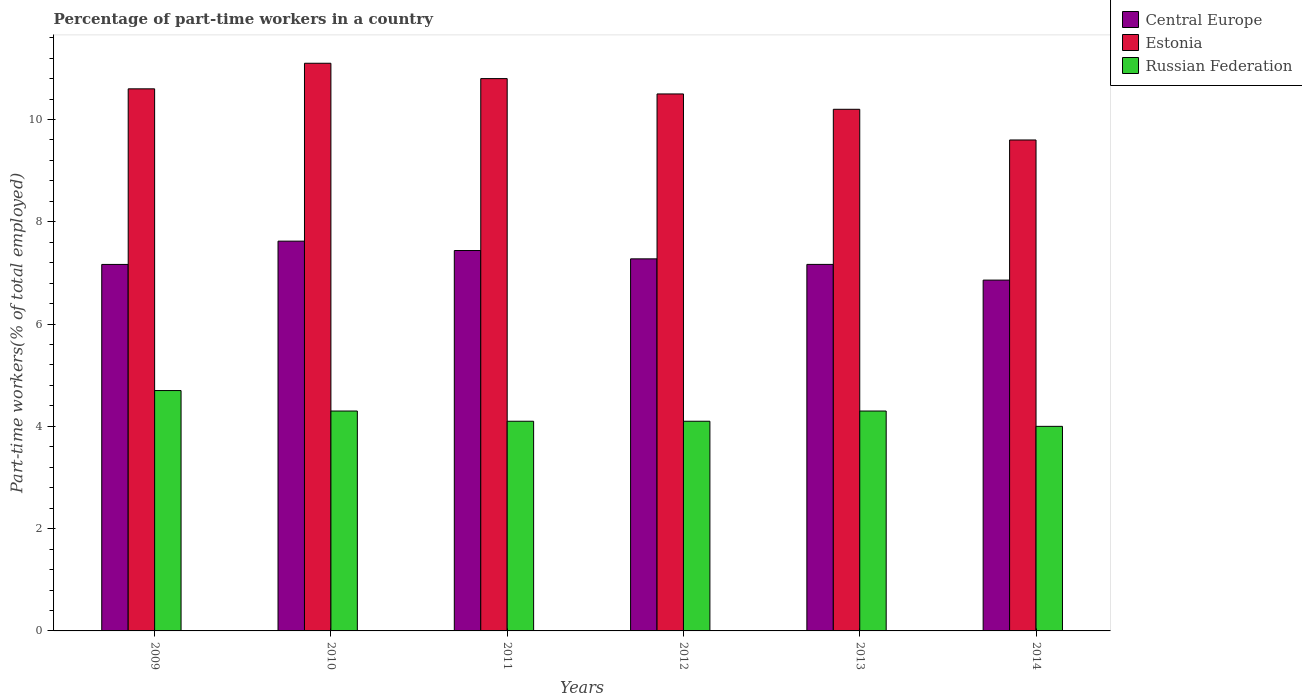Are the number of bars per tick equal to the number of legend labels?
Provide a short and direct response. Yes. Are the number of bars on each tick of the X-axis equal?
Ensure brevity in your answer.  Yes. How many bars are there on the 3rd tick from the right?
Your response must be concise. 3. What is the percentage of part-time workers in Central Europe in 2010?
Ensure brevity in your answer.  7.62. Across all years, what is the maximum percentage of part-time workers in Central Europe?
Provide a succinct answer. 7.62. Across all years, what is the minimum percentage of part-time workers in Central Europe?
Make the answer very short. 6.86. In which year was the percentage of part-time workers in Central Europe maximum?
Provide a succinct answer. 2010. In which year was the percentage of part-time workers in Russian Federation minimum?
Keep it short and to the point. 2014. What is the total percentage of part-time workers in Estonia in the graph?
Make the answer very short. 62.8. What is the difference between the percentage of part-time workers in Russian Federation in 2009 and that in 2012?
Make the answer very short. 0.6. What is the difference between the percentage of part-time workers in Russian Federation in 2010 and the percentage of part-time workers in Central Europe in 2013?
Your response must be concise. -2.87. What is the average percentage of part-time workers in Estonia per year?
Ensure brevity in your answer.  10.47. In the year 2010, what is the difference between the percentage of part-time workers in Russian Federation and percentage of part-time workers in Estonia?
Make the answer very short. -6.8. In how many years, is the percentage of part-time workers in Russian Federation greater than 6 %?
Offer a terse response. 0. What is the ratio of the percentage of part-time workers in Central Europe in 2012 to that in 2013?
Provide a short and direct response. 1.02. Is the difference between the percentage of part-time workers in Russian Federation in 2012 and 2014 greater than the difference between the percentage of part-time workers in Estonia in 2012 and 2014?
Give a very brief answer. No. What is the difference between the highest and the second highest percentage of part-time workers in Estonia?
Offer a terse response. 0.3. What is the difference between the highest and the lowest percentage of part-time workers in Russian Federation?
Your answer should be very brief. 0.7. In how many years, is the percentage of part-time workers in Central Europe greater than the average percentage of part-time workers in Central Europe taken over all years?
Give a very brief answer. 3. Is the sum of the percentage of part-time workers in Estonia in 2009 and 2013 greater than the maximum percentage of part-time workers in Russian Federation across all years?
Your answer should be very brief. Yes. What does the 2nd bar from the left in 2011 represents?
Your answer should be compact. Estonia. What does the 2nd bar from the right in 2013 represents?
Keep it short and to the point. Estonia. How many years are there in the graph?
Your answer should be very brief. 6. Does the graph contain any zero values?
Provide a short and direct response. No. Where does the legend appear in the graph?
Your answer should be very brief. Top right. How many legend labels are there?
Give a very brief answer. 3. How are the legend labels stacked?
Provide a succinct answer. Vertical. What is the title of the graph?
Your answer should be very brief. Percentage of part-time workers in a country. Does "Spain" appear as one of the legend labels in the graph?
Provide a short and direct response. No. What is the label or title of the X-axis?
Your answer should be compact. Years. What is the label or title of the Y-axis?
Offer a terse response. Part-time workers(% of total employed). What is the Part-time workers(% of total employed) in Central Europe in 2009?
Offer a very short reply. 7.17. What is the Part-time workers(% of total employed) of Estonia in 2009?
Ensure brevity in your answer.  10.6. What is the Part-time workers(% of total employed) in Russian Federation in 2009?
Keep it short and to the point. 4.7. What is the Part-time workers(% of total employed) in Central Europe in 2010?
Offer a very short reply. 7.62. What is the Part-time workers(% of total employed) in Estonia in 2010?
Ensure brevity in your answer.  11.1. What is the Part-time workers(% of total employed) of Russian Federation in 2010?
Your answer should be compact. 4.3. What is the Part-time workers(% of total employed) in Central Europe in 2011?
Offer a terse response. 7.44. What is the Part-time workers(% of total employed) of Estonia in 2011?
Offer a very short reply. 10.8. What is the Part-time workers(% of total employed) of Russian Federation in 2011?
Ensure brevity in your answer.  4.1. What is the Part-time workers(% of total employed) in Central Europe in 2012?
Ensure brevity in your answer.  7.28. What is the Part-time workers(% of total employed) of Russian Federation in 2012?
Provide a short and direct response. 4.1. What is the Part-time workers(% of total employed) of Central Europe in 2013?
Provide a succinct answer. 7.17. What is the Part-time workers(% of total employed) in Estonia in 2013?
Your answer should be compact. 10.2. What is the Part-time workers(% of total employed) in Russian Federation in 2013?
Your answer should be compact. 4.3. What is the Part-time workers(% of total employed) of Central Europe in 2014?
Ensure brevity in your answer.  6.86. What is the Part-time workers(% of total employed) of Estonia in 2014?
Offer a very short reply. 9.6. What is the Part-time workers(% of total employed) of Russian Federation in 2014?
Make the answer very short. 4. Across all years, what is the maximum Part-time workers(% of total employed) of Central Europe?
Make the answer very short. 7.62. Across all years, what is the maximum Part-time workers(% of total employed) of Estonia?
Provide a succinct answer. 11.1. Across all years, what is the maximum Part-time workers(% of total employed) in Russian Federation?
Your response must be concise. 4.7. Across all years, what is the minimum Part-time workers(% of total employed) of Central Europe?
Ensure brevity in your answer.  6.86. Across all years, what is the minimum Part-time workers(% of total employed) of Estonia?
Your answer should be very brief. 9.6. What is the total Part-time workers(% of total employed) in Central Europe in the graph?
Make the answer very short. 43.53. What is the total Part-time workers(% of total employed) of Estonia in the graph?
Provide a succinct answer. 62.8. What is the difference between the Part-time workers(% of total employed) of Central Europe in 2009 and that in 2010?
Your response must be concise. -0.46. What is the difference between the Part-time workers(% of total employed) in Estonia in 2009 and that in 2010?
Your answer should be very brief. -0.5. What is the difference between the Part-time workers(% of total employed) in Central Europe in 2009 and that in 2011?
Offer a very short reply. -0.27. What is the difference between the Part-time workers(% of total employed) of Russian Federation in 2009 and that in 2011?
Offer a very short reply. 0.6. What is the difference between the Part-time workers(% of total employed) of Central Europe in 2009 and that in 2012?
Your answer should be very brief. -0.11. What is the difference between the Part-time workers(% of total employed) in Russian Federation in 2009 and that in 2012?
Provide a succinct answer. 0.6. What is the difference between the Part-time workers(% of total employed) of Central Europe in 2009 and that in 2013?
Give a very brief answer. -0. What is the difference between the Part-time workers(% of total employed) in Central Europe in 2009 and that in 2014?
Your response must be concise. 0.31. What is the difference between the Part-time workers(% of total employed) of Estonia in 2009 and that in 2014?
Provide a short and direct response. 1. What is the difference between the Part-time workers(% of total employed) in Central Europe in 2010 and that in 2011?
Give a very brief answer. 0.18. What is the difference between the Part-time workers(% of total employed) in Estonia in 2010 and that in 2011?
Make the answer very short. 0.3. What is the difference between the Part-time workers(% of total employed) in Central Europe in 2010 and that in 2012?
Make the answer very short. 0.35. What is the difference between the Part-time workers(% of total employed) of Russian Federation in 2010 and that in 2012?
Your response must be concise. 0.2. What is the difference between the Part-time workers(% of total employed) in Central Europe in 2010 and that in 2013?
Your response must be concise. 0.45. What is the difference between the Part-time workers(% of total employed) of Russian Federation in 2010 and that in 2013?
Offer a terse response. 0. What is the difference between the Part-time workers(% of total employed) in Central Europe in 2010 and that in 2014?
Give a very brief answer. 0.76. What is the difference between the Part-time workers(% of total employed) of Estonia in 2010 and that in 2014?
Provide a succinct answer. 1.5. What is the difference between the Part-time workers(% of total employed) in Russian Federation in 2010 and that in 2014?
Offer a terse response. 0.3. What is the difference between the Part-time workers(% of total employed) of Central Europe in 2011 and that in 2012?
Provide a succinct answer. 0.16. What is the difference between the Part-time workers(% of total employed) in Estonia in 2011 and that in 2012?
Ensure brevity in your answer.  0.3. What is the difference between the Part-time workers(% of total employed) in Central Europe in 2011 and that in 2013?
Ensure brevity in your answer.  0.27. What is the difference between the Part-time workers(% of total employed) in Russian Federation in 2011 and that in 2013?
Offer a very short reply. -0.2. What is the difference between the Part-time workers(% of total employed) of Central Europe in 2011 and that in 2014?
Ensure brevity in your answer.  0.58. What is the difference between the Part-time workers(% of total employed) of Estonia in 2011 and that in 2014?
Give a very brief answer. 1.2. What is the difference between the Part-time workers(% of total employed) of Russian Federation in 2011 and that in 2014?
Provide a succinct answer. 0.1. What is the difference between the Part-time workers(% of total employed) of Central Europe in 2012 and that in 2013?
Provide a succinct answer. 0.11. What is the difference between the Part-time workers(% of total employed) of Russian Federation in 2012 and that in 2013?
Ensure brevity in your answer.  -0.2. What is the difference between the Part-time workers(% of total employed) of Central Europe in 2012 and that in 2014?
Ensure brevity in your answer.  0.42. What is the difference between the Part-time workers(% of total employed) in Russian Federation in 2012 and that in 2014?
Make the answer very short. 0.1. What is the difference between the Part-time workers(% of total employed) in Central Europe in 2013 and that in 2014?
Offer a very short reply. 0.31. What is the difference between the Part-time workers(% of total employed) in Central Europe in 2009 and the Part-time workers(% of total employed) in Estonia in 2010?
Your response must be concise. -3.93. What is the difference between the Part-time workers(% of total employed) in Central Europe in 2009 and the Part-time workers(% of total employed) in Russian Federation in 2010?
Provide a short and direct response. 2.87. What is the difference between the Part-time workers(% of total employed) in Estonia in 2009 and the Part-time workers(% of total employed) in Russian Federation in 2010?
Offer a terse response. 6.3. What is the difference between the Part-time workers(% of total employed) of Central Europe in 2009 and the Part-time workers(% of total employed) of Estonia in 2011?
Make the answer very short. -3.63. What is the difference between the Part-time workers(% of total employed) of Central Europe in 2009 and the Part-time workers(% of total employed) of Russian Federation in 2011?
Your answer should be very brief. 3.07. What is the difference between the Part-time workers(% of total employed) in Central Europe in 2009 and the Part-time workers(% of total employed) in Estonia in 2012?
Provide a short and direct response. -3.33. What is the difference between the Part-time workers(% of total employed) of Central Europe in 2009 and the Part-time workers(% of total employed) of Russian Federation in 2012?
Your answer should be compact. 3.07. What is the difference between the Part-time workers(% of total employed) in Central Europe in 2009 and the Part-time workers(% of total employed) in Estonia in 2013?
Your answer should be very brief. -3.03. What is the difference between the Part-time workers(% of total employed) in Central Europe in 2009 and the Part-time workers(% of total employed) in Russian Federation in 2013?
Make the answer very short. 2.87. What is the difference between the Part-time workers(% of total employed) in Estonia in 2009 and the Part-time workers(% of total employed) in Russian Federation in 2013?
Your response must be concise. 6.3. What is the difference between the Part-time workers(% of total employed) of Central Europe in 2009 and the Part-time workers(% of total employed) of Estonia in 2014?
Make the answer very short. -2.43. What is the difference between the Part-time workers(% of total employed) in Central Europe in 2009 and the Part-time workers(% of total employed) in Russian Federation in 2014?
Provide a succinct answer. 3.17. What is the difference between the Part-time workers(% of total employed) in Central Europe in 2010 and the Part-time workers(% of total employed) in Estonia in 2011?
Your answer should be very brief. -3.18. What is the difference between the Part-time workers(% of total employed) in Central Europe in 2010 and the Part-time workers(% of total employed) in Russian Federation in 2011?
Keep it short and to the point. 3.52. What is the difference between the Part-time workers(% of total employed) of Estonia in 2010 and the Part-time workers(% of total employed) of Russian Federation in 2011?
Provide a succinct answer. 7. What is the difference between the Part-time workers(% of total employed) of Central Europe in 2010 and the Part-time workers(% of total employed) of Estonia in 2012?
Your response must be concise. -2.88. What is the difference between the Part-time workers(% of total employed) of Central Europe in 2010 and the Part-time workers(% of total employed) of Russian Federation in 2012?
Make the answer very short. 3.52. What is the difference between the Part-time workers(% of total employed) in Central Europe in 2010 and the Part-time workers(% of total employed) in Estonia in 2013?
Your response must be concise. -2.58. What is the difference between the Part-time workers(% of total employed) in Central Europe in 2010 and the Part-time workers(% of total employed) in Russian Federation in 2013?
Offer a very short reply. 3.32. What is the difference between the Part-time workers(% of total employed) of Central Europe in 2010 and the Part-time workers(% of total employed) of Estonia in 2014?
Keep it short and to the point. -1.98. What is the difference between the Part-time workers(% of total employed) in Central Europe in 2010 and the Part-time workers(% of total employed) in Russian Federation in 2014?
Your response must be concise. 3.62. What is the difference between the Part-time workers(% of total employed) in Central Europe in 2011 and the Part-time workers(% of total employed) in Estonia in 2012?
Provide a short and direct response. -3.06. What is the difference between the Part-time workers(% of total employed) of Central Europe in 2011 and the Part-time workers(% of total employed) of Russian Federation in 2012?
Keep it short and to the point. 3.34. What is the difference between the Part-time workers(% of total employed) in Central Europe in 2011 and the Part-time workers(% of total employed) in Estonia in 2013?
Your answer should be compact. -2.76. What is the difference between the Part-time workers(% of total employed) of Central Europe in 2011 and the Part-time workers(% of total employed) of Russian Federation in 2013?
Provide a short and direct response. 3.14. What is the difference between the Part-time workers(% of total employed) in Estonia in 2011 and the Part-time workers(% of total employed) in Russian Federation in 2013?
Offer a very short reply. 6.5. What is the difference between the Part-time workers(% of total employed) in Central Europe in 2011 and the Part-time workers(% of total employed) in Estonia in 2014?
Offer a terse response. -2.16. What is the difference between the Part-time workers(% of total employed) in Central Europe in 2011 and the Part-time workers(% of total employed) in Russian Federation in 2014?
Provide a short and direct response. 3.44. What is the difference between the Part-time workers(% of total employed) of Estonia in 2011 and the Part-time workers(% of total employed) of Russian Federation in 2014?
Give a very brief answer. 6.8. What is the difference between the Part-time workers(% of total employed) of Central Europe in 2012 and the Part-time workers(% of total employed) of Estonia in 2013?
Offer a very short reply. -2.92. What is the difference between the Part-time workers(% of total employed) of Central Europe in 2012 and the Part-time workers(% of total employed) of Russian Federation in 2013?
Offer a very short reply. 2.98. What is the difference between the Part-time workers(% of total employed) of Central Europe in 2012 and the Part-time workers(% of total employed) of Estonia in 2014?
Your answer should be compact. -2.32. What is the difference between the Part-time workers(% of total employed) of Central Europe in 2012 and the Part-time workers(% of total employed) of Russian Federation in 2014?
Provide a short and direct response. 3.28. What is the difference between the Part-time workers(% of total employed) in Estonia in 2012 and the Part-time workers(% of total employed) in Russian Federation in 2014?
Offer a terse response. 6.5. What is the difference between the Part-time workers(% of total employed) in Central Europe in 2013 and the Part-time workers(% of total employed) in Estonia in 2014?
Provide a succinct answer. -2.43. What is the difference between the Part-time workers(% of total employed) of Central Europe in 2013 and the Part-time workers(% of total employed) of Russian Federation in 2014?
Your answer should be compact. 3.17. What is the difference between the Part-time workers(% of total employed) of Estonia in 2013 and the Part-time workers(% of total employed) of Russian Federation in 2014?
Give a very brief answer. 6.2. What is the average Part-time workers(% of total employed) of Central Europe per year?
Provide a short and direct response. 7.25. What is the average Part-time workers(% of total employed) of Estonia per year?
Ensure brevity in your answer.  10.47. What is the average Part-time workers(% of total employed) of Russian Federation per year?
Provide a succinct answer. 4.25. In the year 2009, what is the difference between the Part-time workers(% of total employed) of Central Europe and Part-time workers(% of total employed) of Estonia?
Provide a short and direct response. -3.43. In the year 2009, what is the difference between the Part-time workers(% of total employed) of Central Europe and Part-time workers(% of total employed) of Russian Federation?
Give a very brief answer. 2.47. In the year 2010, what is the difference between the Part-time workers(% of total employed) of Central Europe and Part-time workers(% of total employed) of Estonia?
Keep it short and to the point. -3.48. In the year 2010, what is the difference between the Part-time workers(% of total employed) of Central Europe and Part-time workers(% of total employed) of Russian Federation?
Make the answer very short. 3.32. In the year 2011, what is the difference between the Part-time workers(% of total employed) of Central Europe and Part-time workers(% of total employed) of Estonia?
Keep it short and to the point. -3.36. In the year 2011, what is the difference between the Part-time workers(% of total employed) in Central Europe and Part-time workers(% of total employed) in Russian Federation?
Your answer should be compact. 3.34. In the year 2012, what is the difference between the Part-time workers(% of total employed) of Central Europe and Part-time workers(% of total employed) of Estonia?
Ensure brevity in your answer.  -3.22. In the year 2012, what is the difference between the Part-time workers(% of total employed) of Central Europe and Part-time workers(% of total employed) of Russian Federation?
Your response must be concise. 3.18. In the year 2012, what is the difference between the Part-time workers(% of total employed) in Estonia and Part-time workers(% of total employed) in Russian Federation?
Keep it short and to the point. 6.4. In the year 2013, what is the difference between the Part-time workers(% of total employed) in Central Europe and Part-time workers(% of total employed) in Estonia?
Provide a short and direct response. -3.03. In the year 2013, what is the difference between the Part-time workers(% of total employed) in Central Europe and Part-time workers(% of total employed) in Russian Federation?
Provide a succinct answer. 2.87. In the year 2013, what is the difference between the Part-time workers(% of total employed) in Estonia and Part-time workers(% of total employed) in Russian Federation?
Make the answer very short. 5.9. In the year 2014, what is the difference between the Part-time workers(% of total employed) of Central Europe and Part-time workers(% of total employed) of Estonia?
Offer a very short reply. -2.74. In the year 2014, what is the difference between the Part-time workers(% of total employed) in Central Europe and Part-time workers(% of total employed) in Russian Federation?
Offer a terse response. 2.86. What is the ratio of the Part-time workers(% of total employed) in Central Europe in 2009 to that in 2010?
Ensure brevity in your answer.  0.94. What is the ratio of the Part-time workers(% of total employed) of Estonia in 2009 to that in 2010?
Offer a terse response. 0.95. What is the ratio of the Part-time workers(% of total employed) in Russian Federation in 2009 to that in 2010?
Make the answer very short. 1.09. What is the ratio of the Part-time workers(% of total employed) of Central Europe in 2009 to that in 2011?
Offer a terse response. 0.96. What is the ratio of the Part-time workers(% of total employed) in Estonia in 2009 to that in 2011?
Your response must be concise. 0.98. What is the ratio of the Part-time workers(% of total employed) in Russian Federation in 2009 to that in 2011?
Make the answer very short. 1.15. What is the ratio of the Part-time workers(% of total employed) in Estonia in 2009 to that in 2012?
Provide a succinct answer. 1.01. What is the ratio of the Part-time workers(% of total employed) in Russian Federation in 2009 to that in 2012?
Provide a succinct answer. 1.15. What is the ratio of the Part-time workers(% of total employed) of Estonia in 2009 to that in 2013?
Provide a succinct answer. 1.04. What is the ratio of the Part-time workers(% of total employed) of Russian Federation in 2009 to that in 2013?
Your response must be concise. 1.09. What is the ratio of the Part-time workers(% of total employed) of Central Europe in 2009 to that in 2014?
Offer a terse response. 1.04. What is the ratio of the Part-time workers(% of total employed) in Estonia in 2009 to that in 2014?
Your response must be concise. 1.1. What is the ratio of the Part-time workers(% of total employed) of Russian Federation in 2009 to that in 2014?
Give a very brief answer. 1.18. What is the ratio of the Part-time workers(% of total employed) of Central Europe in 2010 to that in 2011?
Keep it short and to the point. 1.02. What is the ratio of the Part-time workers(% of total employed) in Estonia in 2010 to that in 2011?
Your answer should be compact. 1.03. What is the ratio of the Part-time workers(% of total employed) in Russian Federation in 2010 to that in 2011?
Ensure brevity in your answer.  1.05. What is the ratio of the Part-time workers(% of total employed) in Central Europe in 2010 to that in 2012?
Ensure brevity in your answer.  1.05. What is the ratio of the Part-time workers(% of total employed) of Estonia in 2010 to that in 2012?
Provide a short and direct response. 1.06. What is the ratio of the Part-time workers(% of total employed) in Russian Federation in 2010 to that in 2012?
Offer a very short reply. 1.05. What is the ratio of the Part-time workers(% of total employed) in Central Europe in 2010 to that in 2013?
Your response must be concise. 1.06. What is the ratio of the Part-time workers(% of total employed) of Estonia in 2010 to that in 2013?
Ensure brevity in your answer.  1.09. What is the ratio of the Part-time workers(% of total employed) in Russian Federation in 2010 to that in 2013?
Provide a succinct answer. 1. What is the ratio of the Part-time workers(% of total employed) in Central Europe in 2010 to that in 2014?
Ensure brevity in your answer.  1.11. What is the ratio of the Part-time workers(% of total employed) in Estonia in 2010 to that in 2014?
Keep it short and to the point. 1.16. What is the ratio of the Part-time workers(% of total employed) of Russian Federation in 2010 to that in 2014?
Your response must be concise. 1.07. What is the ratio of the Part-time workers(% of total employed) of Central Europe in 2011 to that in 2012?
Offer a very short reply. 1.02. What is the ratio of the Part-time workers(% of total employed) in Estonia in 2011 to that in 2012?
Offer a very short reply. 1.03. What is the ratio of the Part-time workers(% of total employed) in Central Europe in 2011 to that in 2013?
Offer a terse response. 1.04. What is the ratio of the Part-time workers(% of total employed) in Estonia in 2011 to that in 2013?
Your answer should be very brief. 1.06. What is the ratio of the Part-time workers(% of total employed) of Russian Federation in 2011 to that in 2013?
Your answer should be very brief. 0.95. What is the ratio of the Part-time workers(% of total employed) in Central Europe in 2011 to that in 2014?
Your answer should be very brief. 1.08. What is the ratio of the Part-time workers(% of total employed) in Central Europe in 2012 to that in 2013?
Your response must be concise. 1.02. What is the ratio of the Part-time workers(% of total employed) of Estonia in 2012 to that in 2013?
Provide a short and direct response. 1.03. What is the ratio of the Part-time workers(% of total employed) in Russian Federation in 2012 to that in 2013?
Ensure brevity in your answer.  0.95. What is the ratio of the Part-time workers(% of total employed) of Central Europe in 2012 to that in 2014?
Offer a terse response. 1.06. What is the ratio of the Part-time workers(% of total employed) of Estonia in 2012 to that in 2014?
Your answer should be compact. 1.09. What is the ratio of the Part-time workers(% of total employed) of Central Europe in 2013 to that in 2014?
Keep it short and to the point. 1.04. What is the ratio of the Part-time workers(% of total employed) of Russian Federation in 2013 to that in 2014?
Offer a very short reply. 1.07. What is the difference between the highest and the second highest Part-time workers(% of total employed) of Central Europe?
Your answer should be very brief. 0.18. What is the difference between the highest and the second highest Part-time workers(% of total employed) of Estonia?
Offer a very short reply. 0.3. What is the difference between the highest and the lowest Part-time workers(% of total employed) of Central Europe?
Provide a succinct answer. 0.76. What is the difference between the highest and the lowest Part-time workers(% of total employed) of Estonia?
Give a very brief answer. 1.5. 